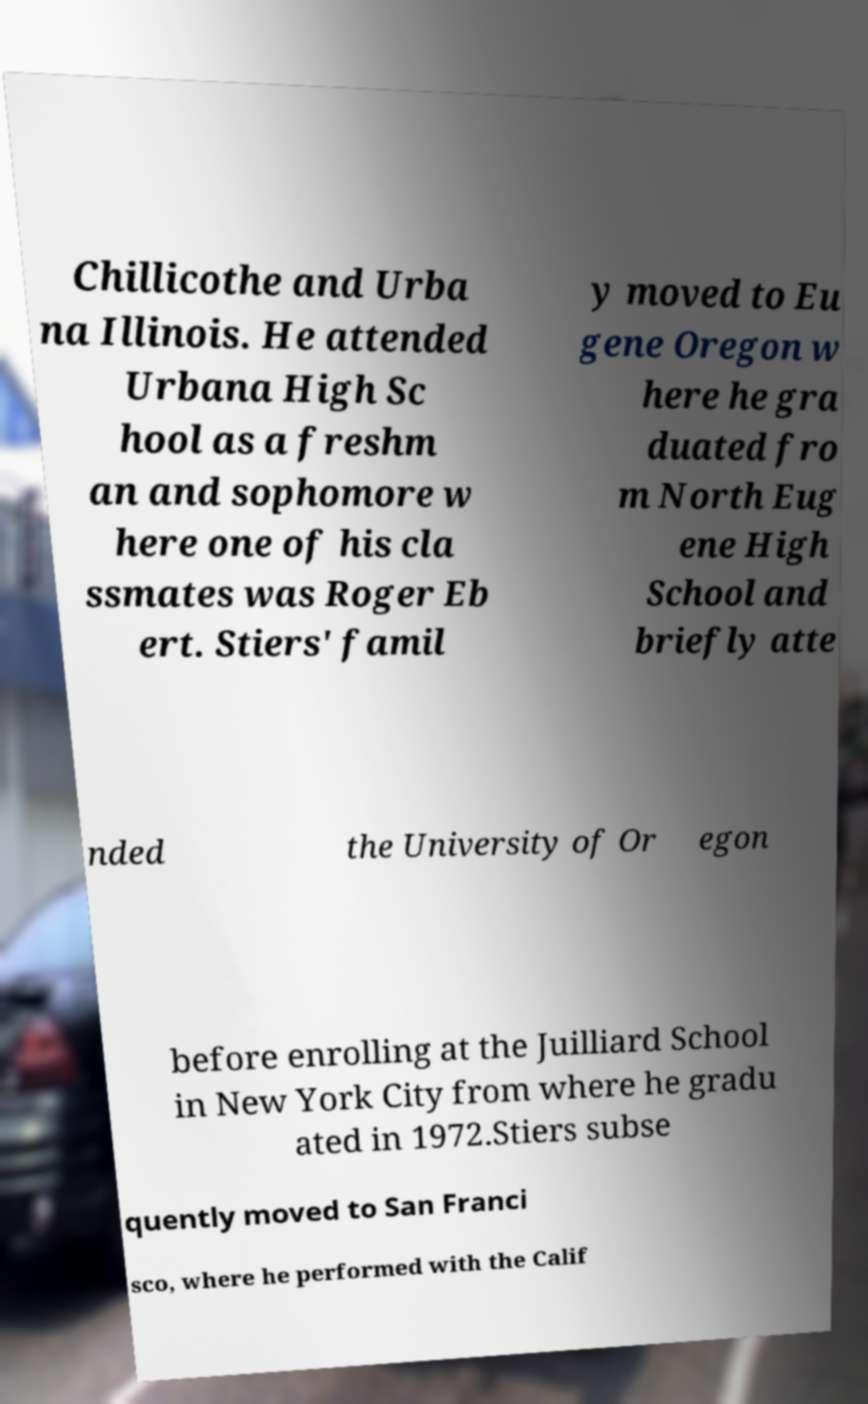Can you accurately transcribe the text from the provided image for me? Chillicothe and Urba na Illinois. He attended Urbana High Sc hool as a freshm an and sophomore w here one of his cla ssmates was Roger Eb ert. Stiers' famil y moved to Eu gene Oregon w here he gra duated fro m North Eug ene High School and briefly atte nded the University of Or egon before enrolling at the Juilliard School in New York City from where he gradu ated in 1972.Stiers subse quently moved to San Franci sco, where he performed with the Calif 